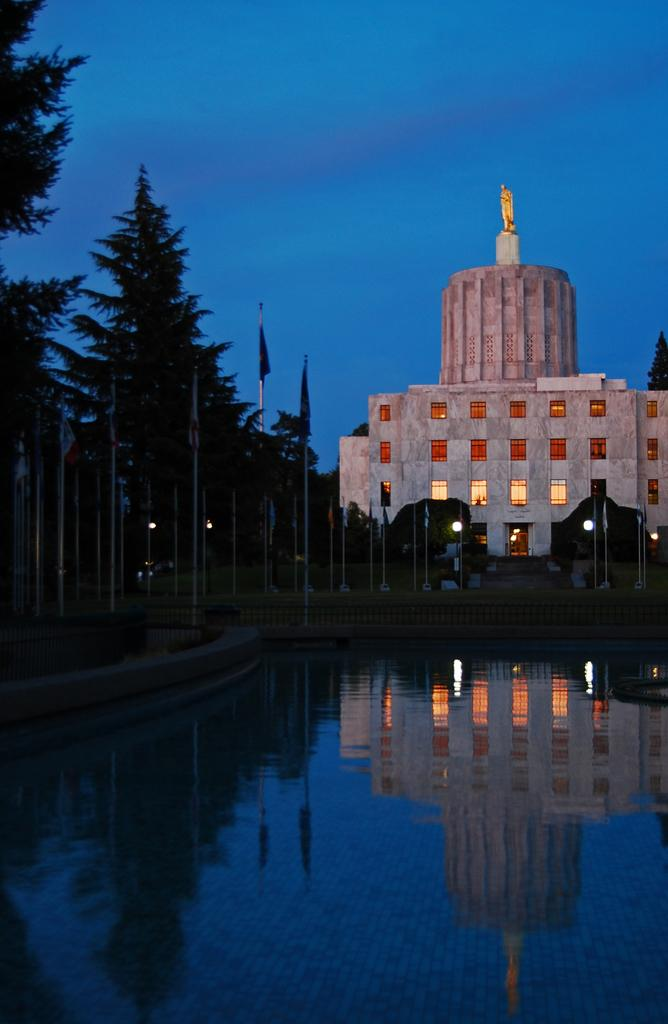What type of structure is present in the image? There is a building in the image. What other natural elements can be seen in the image? There are trees in the image. What architectural features are visible on the building? There are windows in the image. What are the poles used for in the image? The poles are likely used for supporting lights or other fixtures. What is attached to the poles in the image? There are flags attached to the poles. What can be seen in the background of the image? The sky is visible in the background of the image. Is there any water visible in the image? Yes, there is water visible in the image. What type of lighting is present in the image? There are lights in the image. What type of sidewalk can be seen in the image? There is no sidewalk present in the image. What type of leaf is falling from the tree in the image? There is no leaf falling from the tree in the image. 